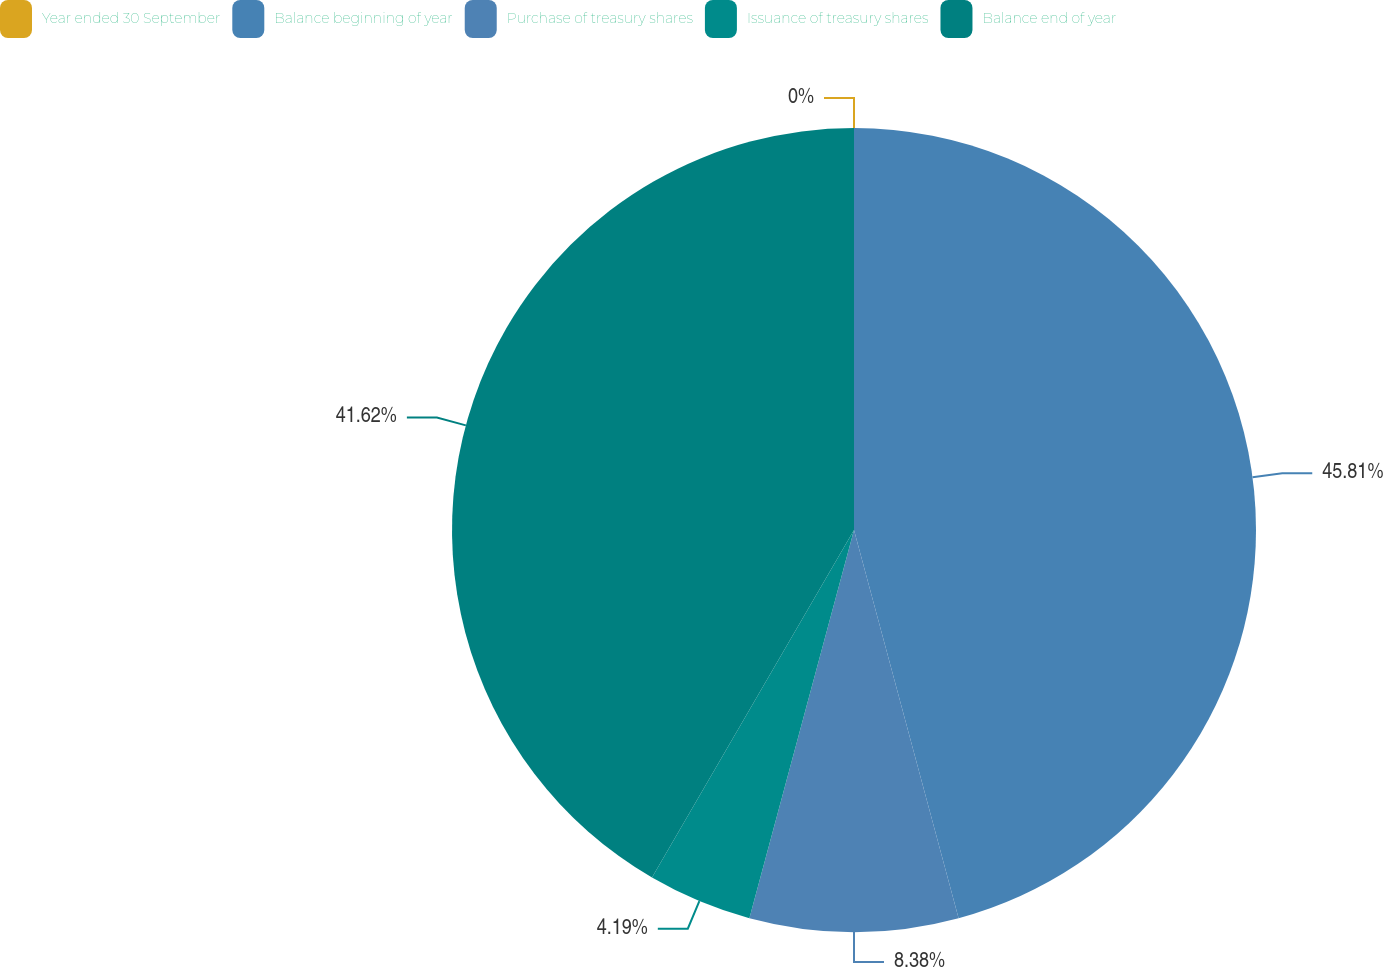<chart> <loc_0><loc_0><loc_500><loc_500><pie_chart><fcel>Year ended 30 September<fcel>Balance beginning of year<fcel>Purchase of treasury shares<fcel>Issuance of treasury shares<fcel>Balance end of year<nl><fcel>0.0%<fcel>45.81%<fcel>8.38%<fcel>4.19%<fcel>41.62%<nl></chart> 